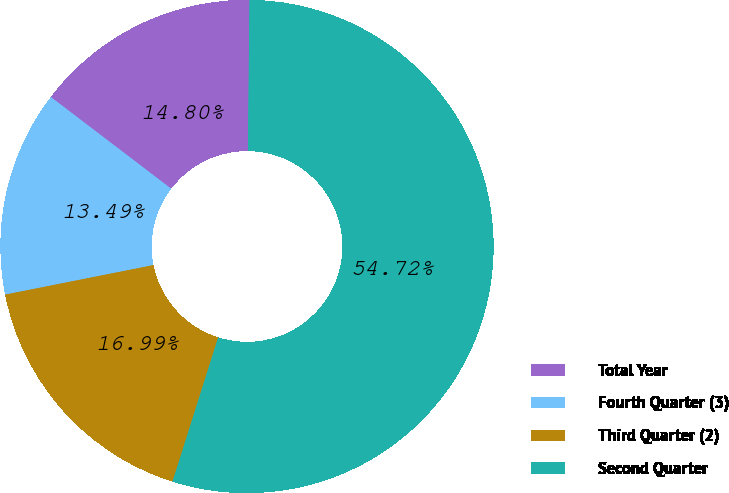Convert chart to OTSL. <chart><loc_0><loc_0><loc_500><loc_500><pie_chart><fcel>Total Year<fcel>Fourth Quarter (3)<fcel>Third Quarter (2)<fcel>Second Quarter<nl><fcel>14.8%<fcel>13.49%<fcel>16.99%<fcel>54.72%<nl></chart> 